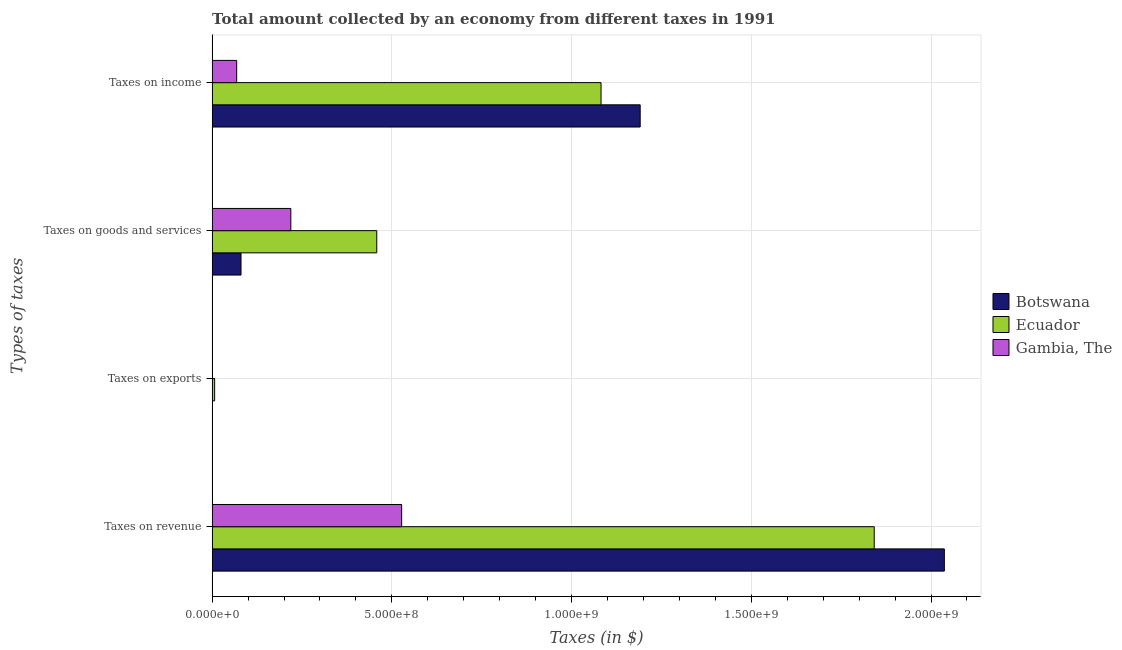How many different coloured bars are there?
Ensure brevity in your answer.  3. Are the number of bars on each tick of the Y-axis equal?
Your answer should be compact. Yes. What is the label of the 4th group of bars from the top?
Your answer should be very brief. Taxes on revenue. What is the amount collected as tax on goods in Gambia, The?
Ensure brevity in your answer.  2.19e+08. Across all countries, what is the maximum amount collected as tax on goods?
Provide a short and direct response. 4.58e+08. Across all countries, what is the minimum amount collected as tax on income?
Provide a succinct answer. 6.83e+07. In which country was the amount collected as tax on exports maximum?
Offer a terse response. Ecuador. In which country was the amount collected as tax on goods minimum?
Offer a very short reply. Botswana. What is the total amount collected as tax on revenue in the graph?
Your answer should be compact. 4.41e+09. What is the difference between the amount collected as tax on goods in Ecuador and that in Gambia, The?
Ensure brevity in your answer.  2.39e+08. What is the difference between the amount collected as tax on goods in Ecuador and the amount collected as tax on exports in Botswana?
Your response must be concise. 4.57e+08. What is the average amount collected as tax on exports per country?
Your answer should be compact. 2.70e+06. What is the difference between the amount collected as tax on goods and amount collected as tax on exports in Ecuador?
Your response must be concise. 4.51e+08. In how many countries, is the amount collected as tax on income greater than 800000000 $?
Provide a succinct answer. 2. What is the ratio of the amount collected as tax on exports in Gambia, The to that in Botswana?
Offer a very short reply. 0.83. Is the difference between the amount collected as tax on goods in Botswana and Ecuador greater than the difference between the amount collected as tax on exports in Botswana and Ecuador?
Ensure brevity in your answer.  No. What is the difference between the highest and the second highest amount collected as tax on goods?
Your response must be concise. 2.39e+08. What is the difference between the highest and the lowest amount collected as tax on income?
Provide a succinct answer. 1.12e+09. What does the 1st bar from the top in Taxes on exports represents?
Your response must be concise. Gambia, The. What does the 2nd bar from the bottom in Taxes on exports represents?
Your response must be concise. Ecuador. Is it the case that in every country, the sum of the amount collected as tax on revenue and amount collected as tax on exports is greater than the amount collected as tax on goods?
Give a very brief answer. Yes. How many bars are there?
Make the answer very short. 12. How many countries are there in the graph?
Provide a succinct answer. 3. Are the values on the major ticks of X-axis written in scientific E-notation?
Keep it short and to the point. Yes. How many legend labels are there?
Provide a short and direct response. 3. How are the legend labels stacked?
Your response must be concise. Vertical. What is the title of the graph?
Make the answer very short. Total amount collected by an economy from different taxes in 1991. Does "Nigeria" appear as one of the legend labels in the graph?
Make the answer very short. No. What is the label or title of the X-axis?
Ensure brevity in your answer.  Taxes (in $). What is the label or title of the Y-axis?
Your response must be concise. Types of taxes. What is the Taxes (in $) of Botswana in Taxes on revenue?
Give a very brief answer. 2.04e+09. What is the Taxes (in $) in Ecuador in Taxes on revenue?
Offer a very short reply. 1.84e+09. What is the Taxes (in $) of Gambia, The in Taxes on revenue?
Make the answer very short. 5.27e+08. What is the Taxes (in $) in Ecuador in Taxes on exports?
Your answer should be very brief. 7.00e+06. What is the Taxes (in $) in Botswana in Taxes on goods and services?
Offer a very short reply. 8.04e+07. What is the Taxes (in $) of Ecuador in Taxes on goods and services?
Offer a terse response. 4.58e+08. What is the Taxes (in $) in Gambia, The in Taxes on goods and services?
Give a very brief answer. 2.19e+08. What is the Taxes (in $) in Botswana in Taxes on income?
Offer a terse response. 1.19e+09. What is the Taxes (in $) of Ecuador in Taxes on income?
Provide a short and direct response. 1.08e+09. What is the Taxes (in $) in Gambia, The in Taxes on income?
Offer a very short reply. 6.83e+07. Across all Types of taxes, what is the maximum Taxes (in $) of Botswana?
Provide a short and direct response. 2.04e+09. Across all Types of taxes, what is the maximum Taxes (in $) of Ecuador?
Provide a succinct answer. 1.84e+09. Across all Types of taxes, what is the maximum Taxes (in $) of Gambia, The?
Keep it short and to the point. 5.27e+08. Across all Types of taxes, what is the minimum Taxes (in $) of Ecuador?
Ensure brevity in your answer.  7.00e+06. What is the total Taxes (in $) in Botswana in the graph?
Keep it short and to the point. 3.31e+09. What is the total Taxes (in $) of Ecuador in the graph?
Offer a very short reply. 3.39e+09. What is the total Taxes (in $) of Gambia, The in the graph?
Provide a succinct answer. 8.15e+08. What is the difference between the Taxes (in $) in Botswana in Taxes on revenue and that in Taxes on exports?
Your response must be concise. 2.04e+09. What is the difference between the Taxes (in $) of Ecuador in Taxes on revenue and that in Taxes on exports?
Provide a succinct answer. 1.84e+09. What is the difference between the Taxes (in $) in Gambia, The in Taxes on revenue and that in Taxes on exports?
Provide a short and direct response. 5.27e+08. What is the difference between the Taxes (in $) in Botswana in Taxes on revenue and that in Taxes on goods and services?
Keep it short and to the point. 1.96e+09. What is the difference between the Taxes (in $) in Ecuador in Taxes on revenue and that in Taxes on goods and services?
Offer a very short reply. 1.38e+09. What is the difference between the Taxes (in $) in Gambia, The in Taxes on revenue and that in Taxes on goods and services?
Keep it short and to the point. 3.08e+08. What is the difference between the Taxes (in $) in Botswana in Taxes on revenue and that in Taxes on income?
Offer a very short reply. 8.46e+08. What is the difference between the Taxes (in $) in Ecuador in Taxes on revenue and that in Taxes on income?
Your response must be concise. 7.60e+08. What is the difference between the Taxes (in $) of Gambia, The in Taxes on revenue and that in Taxes on income?
Offer a terse response. 4.59e+08. What is the difference between the Taxes (in $) in Botswana in Taxes on exports and that in Taxes on goods and services?
Provide a succinct answer. -7.98e+07. What is the difference between the Taxes (in $) of Ecuador in Taxes on exports and that in Taxes on goods and services?
Your answer should be compact. -4.51e+08. What is the difference between the Taxes (in $) of Gambia, The in Taxes on exports and that in Taxes on goods and services?
Provide a short and direct response. -2.18e+08. What is the difference between the Taxes (in $) in Botswana in Taxes on exports and that in Taxes on income?
Your response must be concise. -1.19e+09. What is the difference between the Taxes (in $) of Ecuador in Taxes on exports and that in Taxes on income?
Keep it short and to the point. -1.08e+09. What is the difference between the Taxes (in $) in Gambia, The in Taxes on exports and that in Taxes on income?
Your answer should be compact. -6.78e+07. What is the difference between the Taxes (in $) in Botswana in Taxes on goods and services and that in Taxes on income?
Your response must be concise. -1.11e+09. What is the difference between the Taxes (in $) of Ecuador in Taxes on goods and services and that in Taxes on income?
Offer a very short reply. -6.24e+08. What is the difference between the Taxes (in $) in Gambia, The in Taxes on goods and services and that in Taxes on income?
Give a very brief answer. 1.51e+08. What is the difference between the Taxes (in $) of Botswana in Taxes on revenue and the Taxes (in $) of Ecuador in Taxes on exports?
Provide a short and direct response. 2.03e+09. What is the difference between the Taxes (in $) of Botswana in Taxes on revenue and the Taxes (in $) of Gambia, The in Taxes on exports?
Give a very brief answer. 2.04e+09. What is the difference between the Taxes (in $) of Ecuador in Taxes on revenue and the Taxes (in $) of Gambia, The in Taxes on exports?
Provide a succinct answer. 1.84e+09. What is the difference between the Taxes (in $) in Botswana in Taxes on revenue and the Taxes (in $) in Ecuador in Taxes on goods and services?
Give a very brief answer. 1.58e+09. What is the difference between the Taxes (in $) of Botswana in Taxes on revenue and the Taxes (in $) of Gambia, The in Taxes on goods and services?
Make the answer very short. 1.82e+09. What is the difference between the Taxes (in $) in Ecuador in Taxes on revenue and the Taxes (in $) in Gambia, The in Taxes on goods and services?
Provide a succinct answer. 1.62e+09. What is the difference between the Taxes (in $) of Botswana in Taxes on revenue and the Taxes (in $) of Ecuador in Taxes on income?
Provide a succinct answer. 9.55e+08. What is the difference between the Taxes (in $) of Botswana in Taxes on revenue and the Taxes (in $) of Gambia, The in Taxes on income?
Provide a succinct answer. 1.97e+09. What is the difference between the Taxes (in $) in Ecuador in Taxes on revenue and the Taxes (in $) in Gambia, The in Taxes on income?
Offer a very short reply. 1.77e+09. What is the difference between the Taxes (in $) of Botswana in Taxes on exports and the Taxes (in $) of Ecuador in Taxes on goods and services?
Your answer should be very brief. -4.57e+08. What is the difference between the Taxes (in $) in Botswana in Taxes on exports and the Taxes (in $) in Gambia, The in Taxes on goods and services?
Keep it short and to the point. -2.18e+08. What is the difference between the Taxes (in $) in Ecuador in Taxes on exports and the Taxes (in $) in Gambia, The in Taxes on goods and services?
Your answer should be compact. -2.12e+08. What is the difference between the Taxes (in $) of Botswana in Taxes on exports and the Taxes (in $) of Ecuador in Taxes on income?
Keep it short and to the point. -1.08e+09. What is the difference between the Taxes (in $) in Botswana in Taxes on exports and the Taxes (in $) in Gambia, The in Taxes on income?
Offer a terse response. -6.77e+07. What is the difference between the Taxes (in $) in Ecuador in Taxes on exports and the Taxes (in $) in Gambia, The in Taxes on income?
Keep it short and to the point. -6.13e+07. What is the difference between the Taxes (in $) in Botswana in Taxes on goods and services and the Taxes (in $) in Ecuador in Taxes on income?
Provide a short and direct response. -1.00e+09. What is the difference between the Taxes (in $) of Botswana in Taxes on goods and services and the Taxes (in $) of Gambia, The in Taxes on income?
Ensure brevity in your answer.  1.21e+07. What is the difference between the Taxes (in $) in Ecuador in Taxes on goods and services and the Taxes (in $) in Gambia, The in Taxes on income?
Keep it short and to the point. 3.90e+08. What is the average Taxes (in $) of Botswana per Types of taxes?
Your response must be concise. 8.27e+08. What is the average Taxes (in $) of Ecuador per Types of taxes?
Offer a very short reply. 8.47e+08. What is the average Taxes (in $) of Gambia, The per Types of taxes?
Offer a terse response. 2.04e+08. What is the difference between the Taxes (in $) of Botswana and Taxes (in $) of Ecuador in Taxes on revenue?
Your answer should be very brief. 1.95e+08. What is the difference between the Taxes (in $) of Botswana and Taxes (in $) of Gambia, The in Taxes on revenue?
Offer a terse response. 1.51e+09. What is the difference between the Taxes (in $) in Ecuador and Taxes (in $) in Gambia, The in Taxes on revenue?
Keep it short and to the point. 1.31e+09. What is the difference between the Taxes (in $) of Botswana and Taxes (in $) of Ecuador in Taxes on exports?
Give a very brief answer. -6.40e+06. What is the difference between the Taxes (in $) in Botswana and Taxes (in $) in Gambia, The in Taxes on exports?
Your answer should be very brief. 1.00e+05. What is the difference between the Taxes (in $) of Ecuador and Taxes (in $) of Gambia, The in Taxes on exports?
Offer a terse response. 6.50e+06. What is the difference between the Taxes (in $) in Botswana and Taxes (in $) in Ecuador in Taxes on goods and services?
Offer a terse response. -3.78e+08. What is the difference between the Taxes (in $) in Botswana and Taxes (in $) in Gambia, The in Taxes on goods and services?
Your answer should be compact. -1.39e+08. What is the difference between the Taxes (in $) in Ecuador and Taxes (in $) in Gambia, The in Taxes on goods and services?
Your answer should be very brief. 2.39e+08. What is the difference between the Taxes (in $) of Botswana and Taxes (in $) of Ecuador in Taxes on income?
Your answer should be compact. 1.09e+08. What is the difference between the Taxes (in $) in Botswana and Taxes (in $) in Gambia, The in Taxes on income?
Provide a succinct answer. 1.12e+09. What is the difference between the Taxes (in $) in Ecuador and Taxes (in $) in Gambia, The in Taxes on income?
Offer a very short reply. 1.01e+09. What is the ratio of the Taxes (in $) of Botswana in Taxes on revenue to that in Taxes on exports?
Your answer should be very brief. 3395.17. What is the ratio of the Taxes (in $) of Ecuador in Taxes on revenue to that in Taxes on exports?
Keep it short and to the point. 263.14. What is the ratio of the Taxes (in $) of Gambia, The in Taxes on revenue to that in Taxes on exports?
Provide a succinct answer. 1054.56. What is the ratio of the Taxes (in $) of Botswana in Taxes on revenue to that in Taxes on goods and services?
Give a very brief answer. 25.34. What is the ratio of the Taxes (in $) of Ecuador in Taxes on revenue to that in Taxes on goods and services?
Ensure brevity in your answer.  4.02. What is the ratio of the Taxes (in $) of Gambia, The in Taxes on revenue to that in Taxes on goods and services?
Provide a succinct answer. 2.41. What is the ratio of the Taxes (in $) in Botswana in Taxes on revenue to that in Taxes on income?
Provide a succinct answer. 1.71. What is the ratio of the Taxes (in $) of Ecuador in Taxes on revenue to that in Taxes on income?
Give a very brief answer. 1.7. What is the ratio of the Taxes (in $) of Gambia, The in Taxes on revenue to that in Taxes on income?
Keep it short and to the point. 7.72. What is the ratio of the Taxes (in $) in Botswana in Taxes on exports to that in Taxes on goods and services?
Make the answer very short. 0.01. What is the ratio of the Taxes (in $) in Ecuador in Taxes on exports to that in Taxes on goods and services?
Give a very brief answer. 0.02. What is the ratio of the Taxes (in $) in Gambia, The in Taxes on exports to that in Taxes on goods and services?
Give a very brief answer. 0. What is the ratio of the Taxes (in $) of Ecuador in Taxes on exports to that in Taxes on income?
Ensure brevity in your answer.  0.01. What is the ratio of the Taxes (in $) of Gambia, The in Taxes on exports to that in Taxes on income?
Keep it short and to the point. 0.01. What is the ratio of the Taxes (in $) of Botswana in Taxes on goods and services to that in Taxes on income?
Make the answer very short. 0.07. What is the ratio of the Taxes (in $) of Ecuador in Taxes on goods and services to that in Taxes on income?
Provide a short and direct response. 0.42. What is the ratio of the Taxes (in $) of Gambia, The in Taxes on goods and services to that in Taxes on income?
Make the answer very short. 3.2. What is the difference between the highest and the second highest Taxes (in $) in Botswana?
Provide a succinct answer. 8.46e+08. What is the difference between the highest and the second highest Taxes (in $) of Ecuador?
Your answer should be very brief. 7.60e+08. What is the difference between the highest and the second highest Taxes (in $) in Gambia, The?
Keep it short and to the point. 3.08e+08. What is the difference between the highest and the lowest Taxes (in $) of Botswana?
Offer a terse response. 2.04e+09. What is the difference between the highest and the lowest Taxes (in $) of Ecuador?
Keep it short and to the point. 1.84e+09. What is the difference between the highest and the lowest Taxes (in $) of Gambia, The?
Make the answer very short. 5.27e+08. 